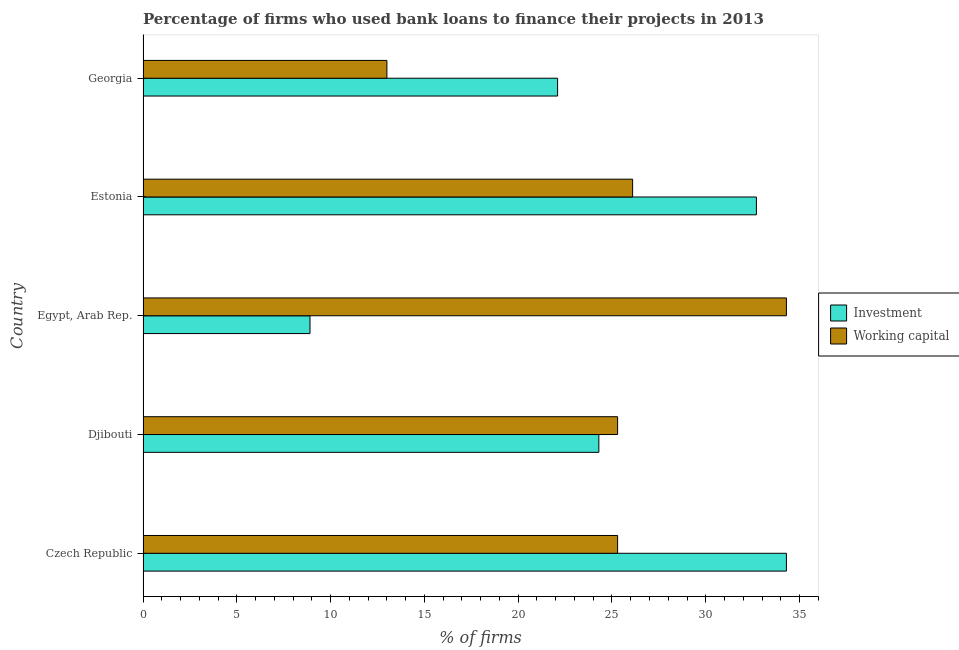How many different coloured bars are there?
Give a very brief answer. 2. Are the number of bars per tick equal to the number of legend labels?
Offer a very short reply. Yes. Are the number of bars on each tick of the Y-axis equal?
Make the answer very short. Yes. What is the label of the 1st group of bars from the top?
Provide a short and direct response. Georgia. In how many cases, is the number of bars for a given country not equal to the number of legend labels?
Your answer should be compact. 0. What is the percentage of firms using banks to finance investment in Djibouti?
Offer a terse response. 24.3. Across all countries, what is the maximum percentage of firms using banks to finance investment?
Make the answer very short. 34.3. Across all countries, what is the minimum percentage of firms using banks to finance investment?
Make the answer very short. 8.9. In which country was the percentage of firms using banks to finance investment maximum?
Provide a succinct answer. Czech Republic. In which country was the percentage of firms using banks to finance investment minimum?
Keep it short and to the point. Egypt, Arab Rep. What is the total percentage of firms using banks to finance investment in the graph?
Keep it short and to the point. 122.3. What is the difference between the percentage of firms using banks to finance working capital in Estonia and the percentage of firms using banks to finance investment in Djibouti?
Your response must be concise. 1.8. What is the average percentage of firms using banks to finance investment per country?
Your answer should be compact. 24.46. What is the difference between the percentage of firms using banks to finance investment and percentage of firms using banks to finance working capital in Czech Republic?
Your response must be concise. 9. In how many countries, is the percentage of firms using banks to finance investment greater than 13 %?
Ensure brevity in your answer.  4. What is the ratio of the percentage of firms using banks to finance working capital in Czech Republic to that in Egypt, Arab Rep.?
Your answer should be very brief. 0.74. Is the percentage of firms using banks to finance investment in Czech Republic less than that in Egypt, Arab Rep.?
Give a very brief answer. No. Is the difference between the percentage of firms using banks to finance working capital in Czech Republic and Estonia greater than the difference between the percentage of firms using banks to finance investment in Czech Republic and Estonia?
Offer a very short reply. No. What is the difference between the highest and the second highest percentage of firms using banks to finance investment?
Offer a terse response. 1.6. What is the difference between the highest and the lowest percentage of firms using banks to finance working capital?
Give a very brief answer. 21.3. In how many countries, is the percentage of firms using banks to finance working capital greater than the average percentage of firms using banks to finance working capital taken over all countries?
Provide a succinct answer. 4. Is the sum of the percentage of firms using banks to finance investment in Czech Republic and Egypt, Arab Rep. greater than the maximum percentage of firms using banks to finance working capital across all countries?
Make the answer very short. Yes. What does the 1st bar from the top in Egypt, Arab Rep. represents?
Your response must be concise. Working capital. What does the 2nd bar from the bottom in Djibouti represents?
Give a very brief answer. Working capital. How many bars are there?
Your answer should be very brief. 10. Are all the bars in the graph horizontal?
Provide a succinct answer. Yes. How many countries are there in the graph?
Keep it short and to the point. 5. Are the values on the major ticks of X-axis written in scientific E-notation?
Make the answer very short. No. Does the graph contain grids?
Keep it short and to the point. No. Where does the legend appear in the graph?
Provide a succinct answer. Center right. How many legend labels are there?
Give a very brief answer. 2. How are the legend labels stacked?
Provide a short and direct response. Vertical. What is the title of the graph?
Your answer should be very brief. Percentage of firms who used bank loans to finance their projects in 2013. What is the label or title of the X-axis?
Your answer should be compact. % of firms. What is the % of firms in Investment in Czech Republic?
Your answer should be very brief. 34.3. What is the % of firms of Working capital in Czech Republic?
Provide a succinct answer. 25.3. What is the % of firms of Investment in Djibouti?
Give a very brief answer. 24.3. What is the % of firms in Working capital in Djibouti?
Provide a succinct answer. 25.3. What is the % of firms in Investment in Egypt, Arab Rep.?
Your answer should be very brief. 8.9. What is the % of firms of Working capital in Egypt, Arab Rep.?
Offer a terse response. 34.3. What is the % of firms of Investment in Estonia?
Your answer should be compact. 32.7. What is the % of firms in Working capital in Estonia?
Your response must be concise. 26.1. What is the % of firms of Investment in Georgia?
Your answer should be very brief. 22.1. What is the % of firms of Working capital in Georgia?
Your answer should be very brief. 13. Across all countries, what is the maximum % of firms in Investment?
Provide a short and direct response. 34.3. Across all countries, what is the maximum % of firms of Working capital?
Offer a very short reply. 34.3. Across all countries, what is the minimum % of firms in Investment?
Give a very brief answer. 8.9. Across all countries, what is the minimum % of firms of Working capital?
Your response must be concise. 13. What is the total % of firms of Investment in the graph?
Keep it short and to the point. 122.3. What is the total % of firms of Working capital in the graph?
Give a very brief answer. 124. What is the difference between the % of firms in Working capital in Czech Republic and that in Djibouti?
Provide a short and direct response. 0. What is the difference between the % of firms in Investment in Czech Republic and that in Egypt, Arab Rep.?
Offer a very short reply. 25.4. What is the difference between the % of firms in Working capital in Czech Republic and that in Egypt, Arab Rep.?
Your answer should be very brief. -9. What is the difference between the % of firms of Investment in Czech Republic and that in Estonia?
Your response must be concise. 1.6. What is the difference between the % of firms in Working capital in Czech Republic and that in Georgia?
Offer a terse response. 12.3. What is the difference between the % of firms of Investment in Djibouti and that in Egypt, Arab Rep.?
Offer a terse response. 15.4. What is the difference between the % of firms of Working capital in Djibouti and that in Egypt, Arab Rep.?
Your answer should be very brief. -9. What is the difference between the % of firms of Investment in Djibouti and that in Estonia?
Give a very brief answer. -8.4. What is the difference between the % of firms in Working capital in Djibouti and that in Estonia?
Give a very brief answer. -0.8. What is the difference between the % of firms in Working capital in Djibouti and that in Georgia?
Give a very brief answer. 12.3. What is the difference between the % of firms in Investment in Egypt, Arab Rep. and that in Estonia?
Give a very brief answer. -23.8. What is the difference between the % of firms of Working capital in Egypt, Arab Rep. and that in Estonia?
Provide a short and direct response. 8.2. What is the difference between the % of firms of Investment in Egypt, Arab Rep. and that in Georgia?
Make the answer very short. -13.2. What is the difference between the % of firms of Working capital in Egypt, Arab Rep. and that in Georgia?
Provide a short and direct response. 21.3. What is the difference between the % of firms of Working capital in Estonia and that in Georgia?
Your answer should be compact. 13.1. What is the difference between the % of firms in Investment in Czech Republic and the % of firms in Working capital in Egypt, Arab Rep.?
Keep it short and to the point. 0. What is the difference between the % of firms in Investment in Czech Republic and the % of firms in Working capital in Estonia?
Offer a very short reply. 8.2. What is the difference between the % of firms of Investment in Czech Republic and the % of firms of Working capital in Georgia?
Your response must be concise. 21.3. What is the difference between the % of firms in Investment in Djibouti and the % of firms in Working capital in Estonia?
Provide a succinct answer. -1.8. What is the difference between the % of firms of Investment in Djibouti and the % of firms of Working capital in Georgia?
Your answer should be very brief. 11.3. What is the difference between the % of firms of Investment in Egypt, Arab Rep. and the % of firms of Working capital in Estonia?
Keep it short and to the point. -17.2. What is the difference between the % of firms of Investment in Egypt, Arab Rep. and the % of firms of Working capital in Georgia?
Provide a succinct answer. -4.1. What is the average % of firms in Investment per country?
Make the answer very short. 24.46. What is the average % of firms of Working capital per country?
Your answer should be very brief. 24.8. What is the difference between the % of firms in Investment and % of firms in Working capital in Egypt, Arab Rep.?
Your answer should be very brief. -25.4. What is the difference between the % of firms of Investment and % of firms of Working capital in Georgia?
Offer a terse response. 9.1. What is the ratio of the % of firms in Investment in Czech Republic to that in Djibouti?
Provide a short and direct response. 1.41. What is the ratio of the % of firms of Working capital in Czech Republic to that in Djibouti?
Ensure brevity in your answer.  1. What is the ratio of the % of firms in Investment in Czech Republic to that in Egypt, Arab Rep.?
Provide a succinct answer. 3.85. What is the ratio of the % of firms in Working capital in Czech Republic to that in Egypt, Arab Rep.?
Offer a very short reply. 0.74. What is the ratio of the % of firms in Investment in Czech Republic to that in Estonia?
Give a very brief answer. 1.05. What is the ratio of the % of firms in Working capital in Czech Republic to that in Estonia?
Make the answer very short. 0.97. What is the ratio of the % of firms of Investment in Czech Republic to that in Georgia?
Ensure brevity in your answer.  1.55. What is the ratio of the % of firms in Working capital in Czech Republic to that in Georgia?
Your response must be concise. 1.95. What is the ratio of the % of firms of Investment in Djibouti to that in Egypt, Arab Rep.?
Your answer should be very brief. 2.73. What is the ratio of the % of firms in Working capital in Djibouti to that in Egypt, Arab Rep.?
Ensure brevity in your answer.  0.74. What is the ratio of the % of firms in Investment in Djibouti to that in Estonia?
Ensure brevity in your answer.  0.74. What is the ratio of the % of firms in Working capital in Djibouti to that in Estonia?
Your answer should be compact. 0.97. What is the ratio of the % of firms in Investment in Djibouti to that in Georgia?
Keep it short and to the point. 1.1. What is the ratio of the % of firms in Working capital in Djibouti to that in Georgia?
Make the answer very short. 1.95. What is the ratio of the % of firms of Investment in Egypt, Arab Rep. to that in Estonia?
Provide a succinct answer. 0.27. What is the ratio of the % of firms in Working capital in Egypt, Arab Rep. to that in Estonia?
Keep it short and to the point. 1.31. What is the ratio of the % of firms in Investment in Egypt, Arab Rep. to that in Georgia?
Make the answer very short. 0.4. What is the ratio of the % of firms of Working capital in Egypt, Arab Rep. to that in Georgia?
Give a very brief answer. 2.64. What is the ratio of the % of firms in Investment in Estonia to that in Georgia?
Ensure brevity in your answer.  1.48. What is the ratio of the % of firms in Working capital in Estonia to that in Georgia?
Your answer should be very brief. 2.01. What is the difference between the highest and the lowest % of firms in Investment?
Offer a terse response. 25.4. What is the difference between the highest and the lowest % of firms of Working capital?
Provide a succinct answer. 21.3. 